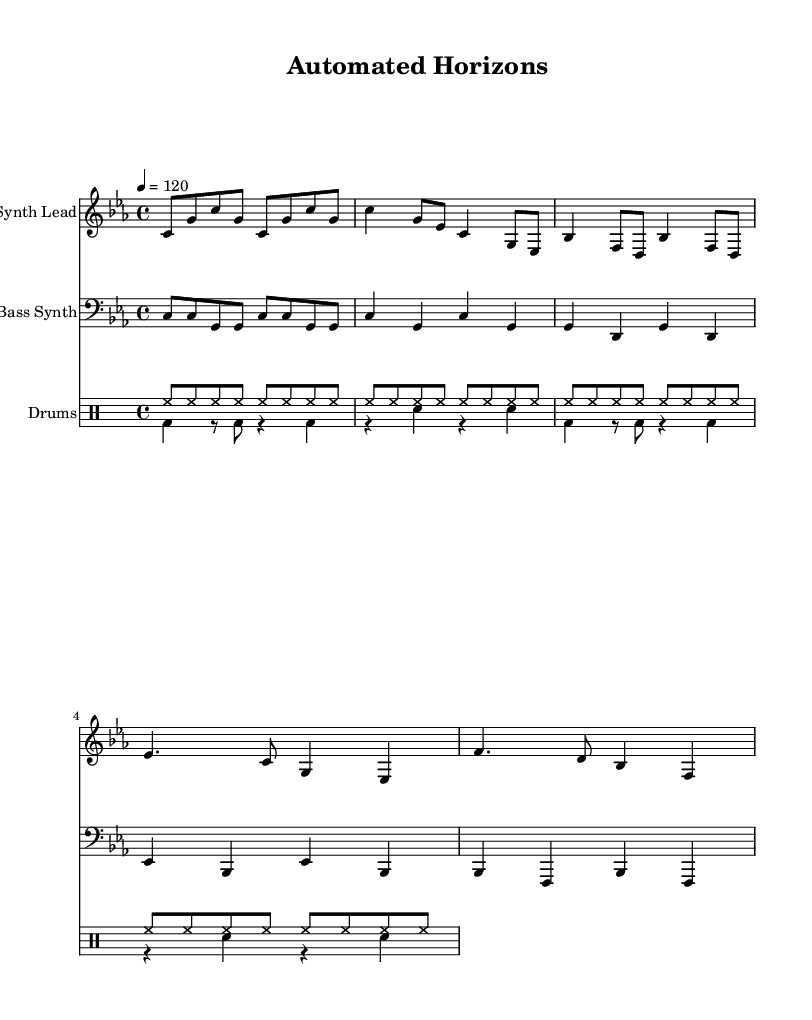What is the key signature of this music? The key signature is C minor, which has three flats (B, E, and A).
Answer: C minor What is the time signature of this music? The time signature shown in the music is 4/4, meaning there are four beats in each measure.
Answer: 4/4 What is the tempo marking for the piece? The tempo marking is indicated to be 120 beats per minute, which suggests a moderate pace for the music.
Answer: 120 How many measures are in the chorus section of the piece? By counting the measures in the chorus section, there are a total of four measures.
Answer: 4 In the drum pattern, how many times does the hi-hat repeat in the first four measures? The hi-hat pattern is repeated eight times in each measure for a total of 32 hi-hat notes during the first four measures.
Answer: 32 What type of synthesizer sound is used for the lead? The music indicates a synthesizer is used for the lead instrument, creating an electronic sound.
Answer: Synth Lead What rhythmic feel is emphasized by the Kick and Snare pattern? The Kick and Snare pattern emphasizes a steady and driving dance rhythm, typical in electronic and industrial music.
Answer: Steady driving rhythm 